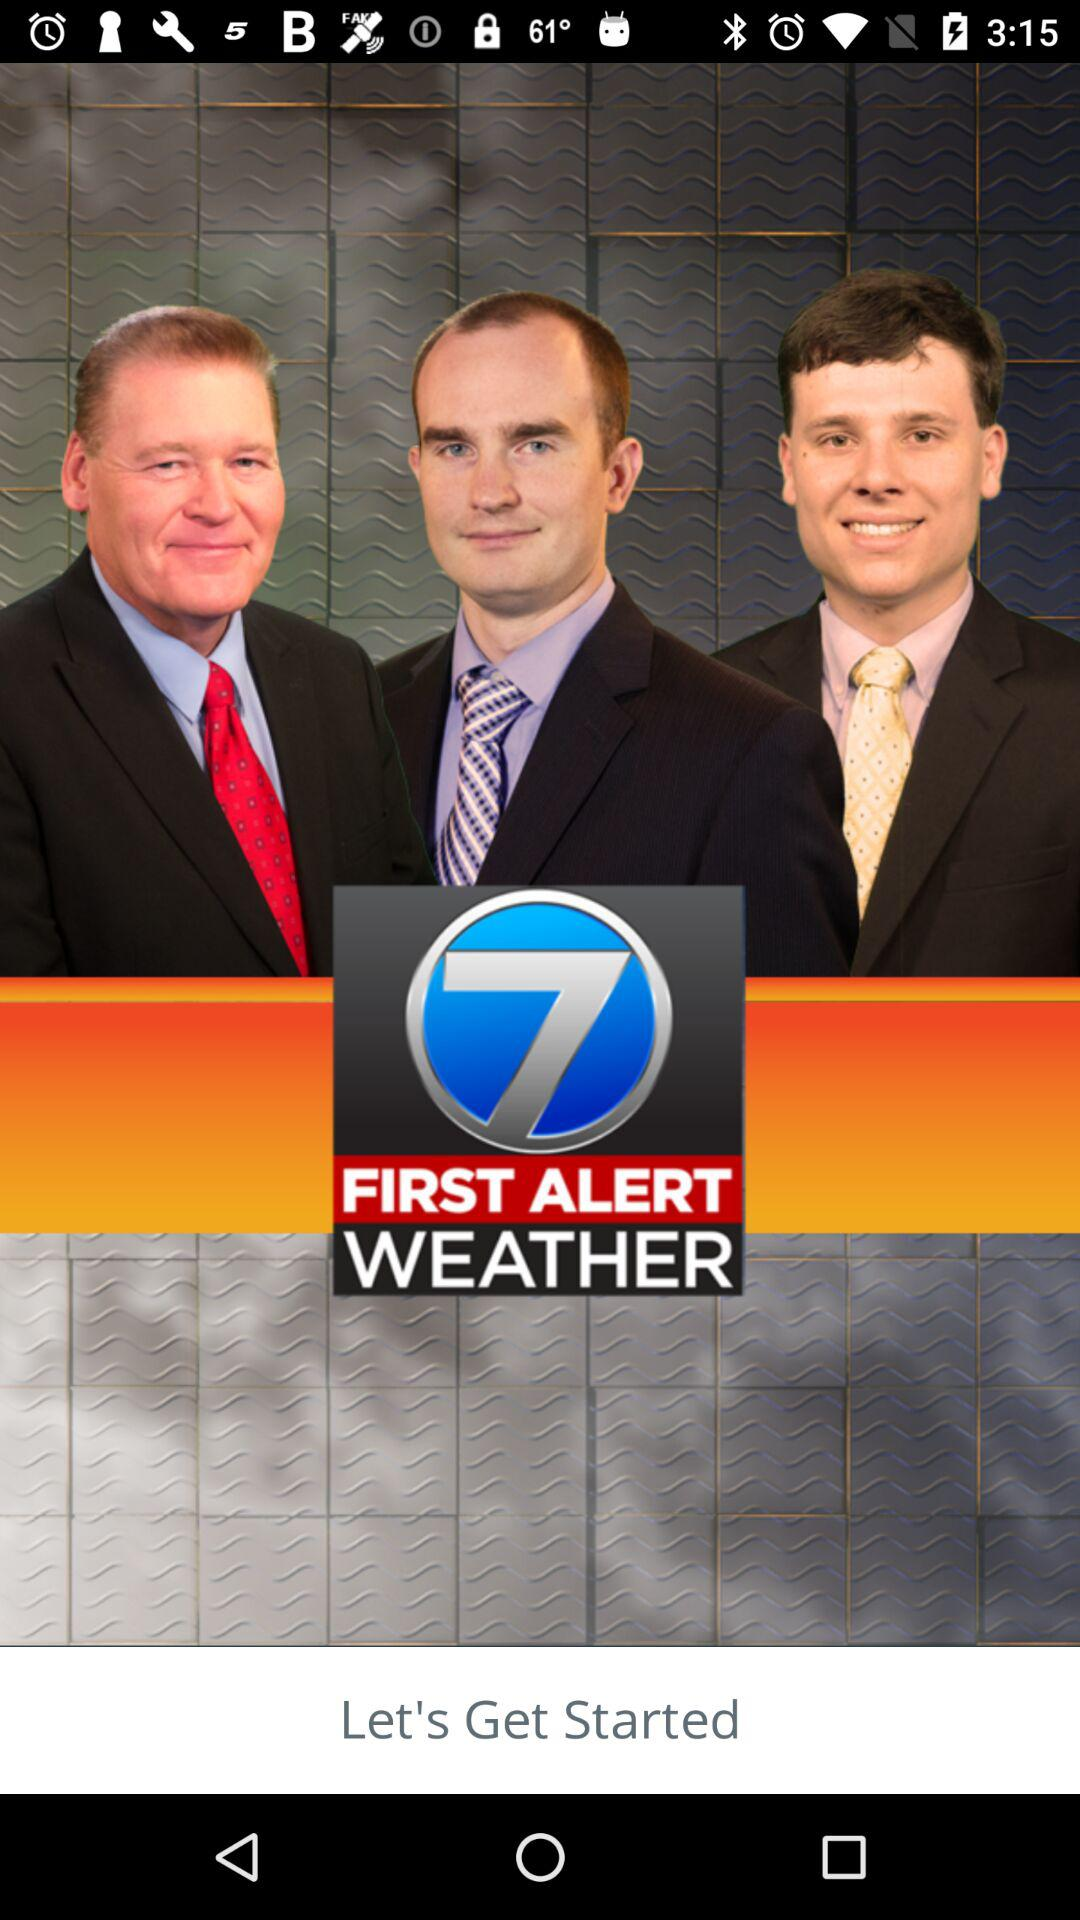What is the application name? The application name is "7 FIRST ALERT WEATHER". 